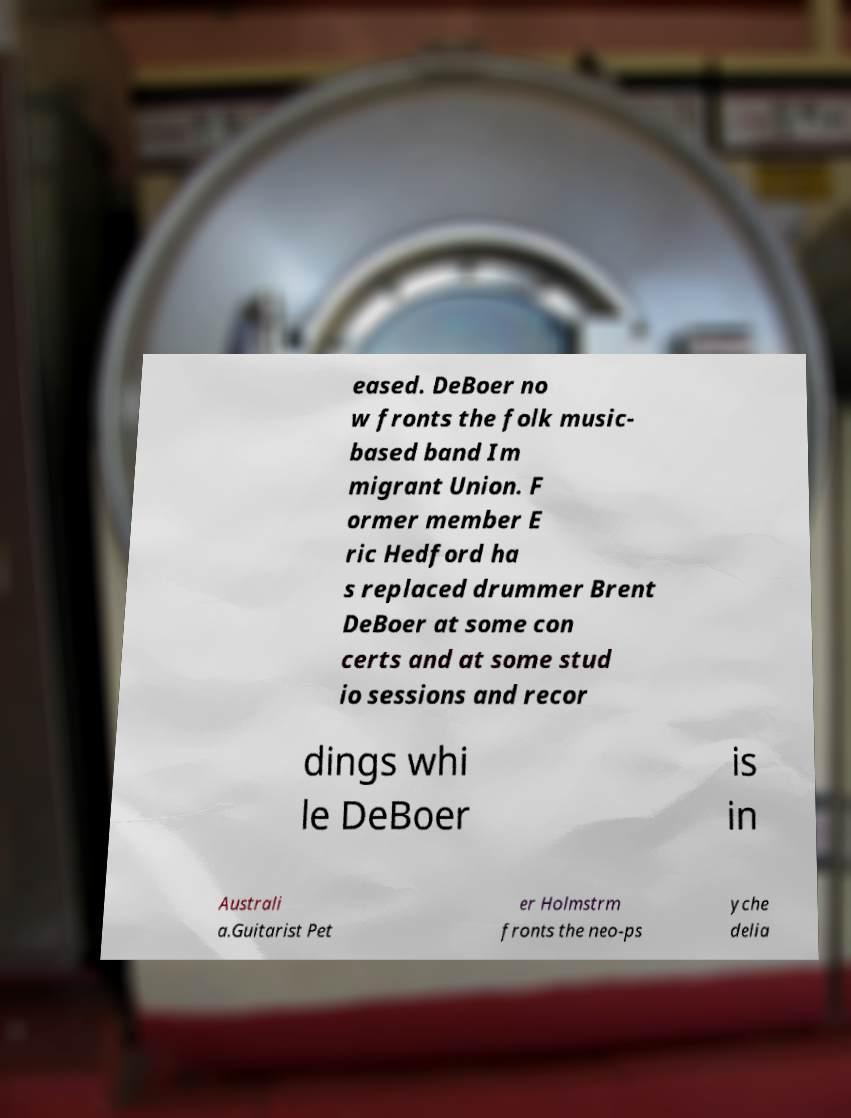Could you assist in decoding the text presented in this image and type it out clearly? eased. DeBoer no w fronts the folk music- based band Im migrant Union. F ormer member E ric Hedford ha s replaced drummer Brent DeBoer at some con certs and at some stud io sessions and recor dings whi le DeBoer is in Australi a.Guitarist Pet er Holmstrm fronts the neo-ps yche delia 